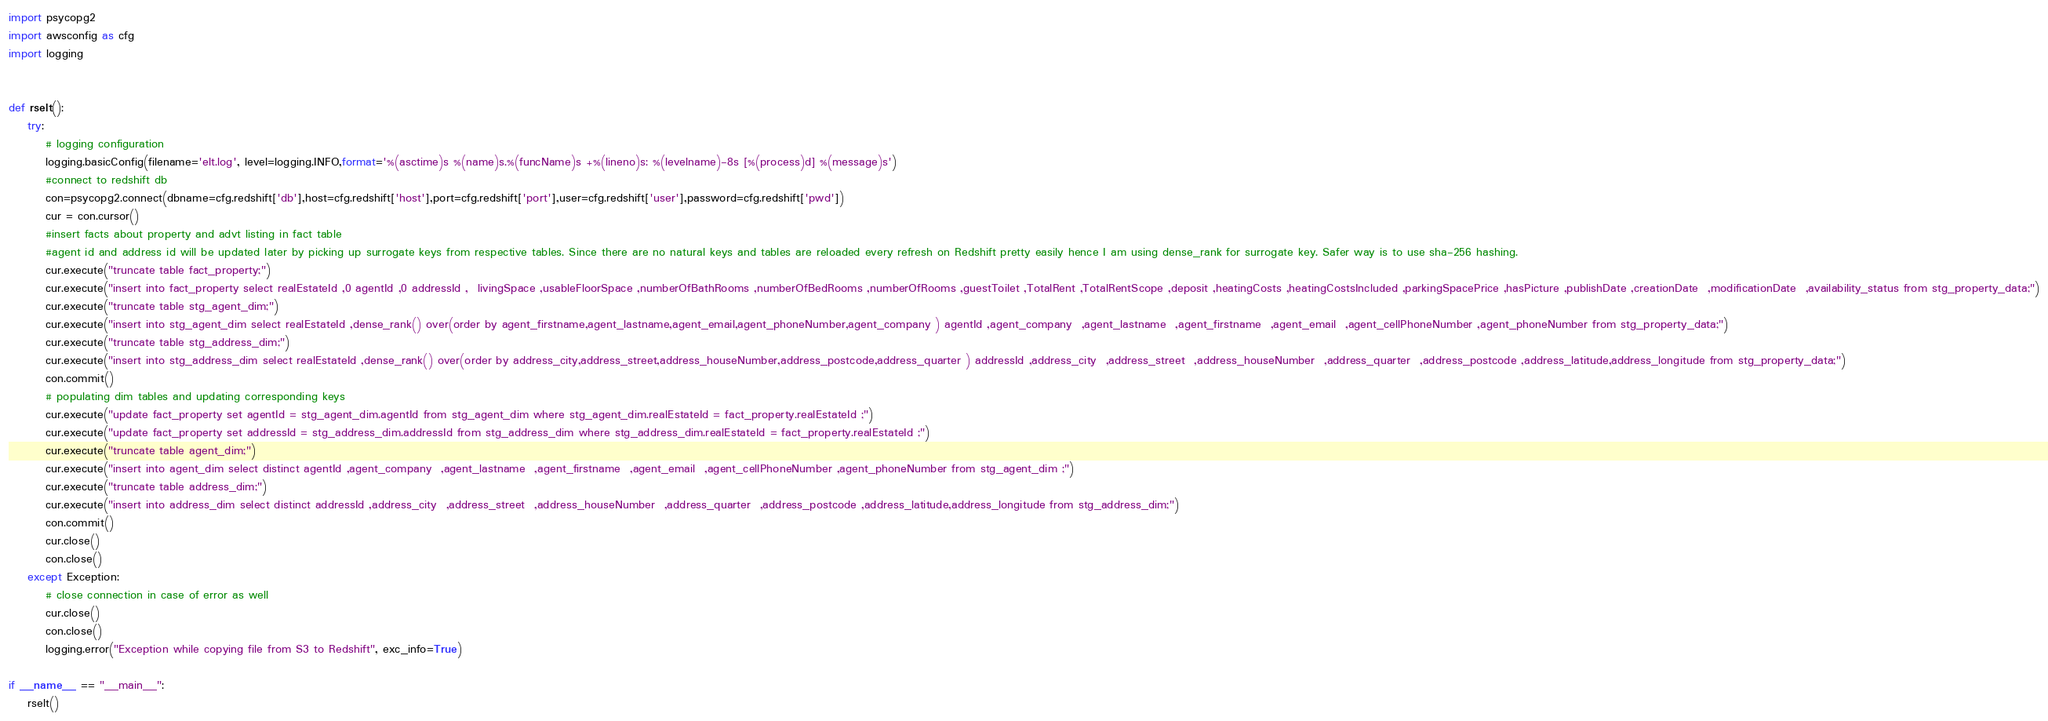Convert code to text. <code><loc_0><loc_0><loc_500><loc_500><_Python_>import psycopg2
import awsconfig as cfg
import logging


def rselt():
    try:
        # logging configuration
        logging.basicConfig(filename='elt.log', level=logging.INFO,format='%(asctime)s %(name)s.%(funcName)s +%(lineno)s: %(levelname)-8s [%(process)d] %(message)s')
        #connect to redshift db
        con=psycopg2.connect(dbname=cfg.redshift['db'],host=cfg.redshift['host'],port=cfg.redshift['port'],user=cfg.redshift['user'],password=cfg.redshift['pwd'])
        cur = con.cursor()
        #insert facts about property and advt listing in fact table
        #agent id and address id will be updated later by picking up surrogate keys from respective tables. Since there are no natural keys and tables are reloaded every refresh on Redshift pretty easily hence I am using dense_rank for surrogate key. Safer way is to use sha-256 hashing.  
        cur.execute("truncate table fact_property;")
        cur.execute("insert into fact_property select realEstateId ,0 agentId ,0 addressId ,  livingSpace ,usableFloorSpace ,numberOfBathRooms ,numberOfBedRooms ,numberOfRooms ,guestToilet ,TotalRent ,TotalRentScope ,deposit ,heatingCosts ,heatingCostsIncluded ,parkingSpacePrice ,hasPicture ,publishDate ,creationDate  ,modificationDate  ,availability_status from stg_property_data;")
        cur.execute("truncate table stg_agent_dim;")
        cur.execute("insert into stg_agent_dim select realEstateId ,dense_rank() over(order by agent_firstname,agent_lastname,agent_email,agent_phoneNumber,agent_company ) agentId ,agent_company  ,agent_lastname  ,agent_firstname  ,agent_email  ,agent_cellPhoneNumber ,agent_phoneNumber from stg_property_data;")
        cur.execute("truncate table stg_address_dim;")
        cur.execute("insert into stg_address_dim select realEstateId ,dense_rank() over(order by address_city,address_street,address_houseNumber,address_postcode,address_quarter ) addressId ,address_city  ,address_street  ,address_houseNumber  ,address_quarter  ,address_postcode ,address_latitude,address_longitude from stg_property_data;")
        con.commit()
        # populating dim tables and updating corresponding keys
        cur.execute("update fact_property set agentId = stg_agent_dim.agentId from stg_agent_dim where stg_agent_dim.realEstateId = fact_property.realEstateId ;")
        cur.execute("update fact_property set addressId = stg_address_dim.addressId from stg_address_dim where stg_address_dim.realEstateId = fact_property.realEstateId ;")
        cur.execute("truncate table agent_dim;")
        cur.execute("insert into agent_dim select distinct agentId ,agent_company  ,agent_lastname  ,agent_firstname  ,agent_email  ,agent_cellPhoneNumber ,agent_phoneNumber from stg_agent_dim ;")
        cur.execute("truncate table address_dim;")
        cur.execute("insert into address_dim select distinct addressId ,address_city  ,address_street  ,address_houseNumber  ,address_quarter  ,address_postcode ,address_latitude,address_longitude from stg_address_dim;")
        con.commit()
        cur.close()
        con.close()
    except Exception:
        # close connection in case of error as well
        cur.close()
        con.close()
        logging.error("Exception while copying file from S3 to Redshift", exc_info=True)    
    
if __name__ == "__main__":
    rselt()
</code> 